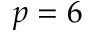Convert formula to latex. <formula><loc_0><loc_0><loc_500><loc_500>p = 6</formula> 